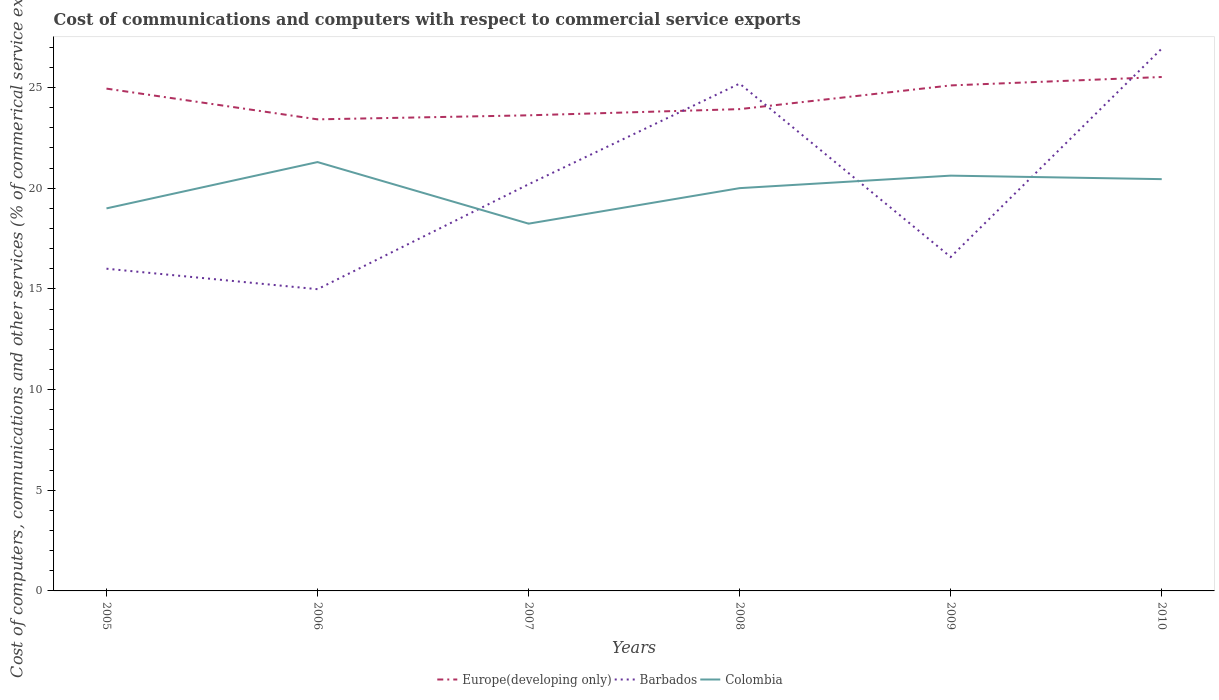Does the line corresponding to Europe(developing only) intersect with the line corresponding to Barbados?
Keep it short and to the point. Yes. Across all years, what is the maximum cost of communications and computers in Europe(developing only)?
Ensure brevity in your answer.  23.42. What is the total cost of communications and computers in Colombia in the graph?
Offer a terse response. 3.06. What is the difference between the highest and the second highest cost of communications and computers in Colombia?
Make the answer very short. 3.06. What is the difference between the highest and the lowest cost of communications and computers in Colombia?
Offer a very short reply. 4. Is the cost of communications and computers in Colombia strictly greater than the cost of communications and computers in Barbados over the years?
Your answer should be compact. No. Does the graph contain grids?
Offer a terse response. No. Where does the legend appear in the graph?
Keep it short and to the point. Bottom center. How many legend labels are there?
Offer a terse response. 3. What is the title of the graph?
Provide a succinct answer. Cost of communications and computers with respect to commercial service exports. What is the label or title of the X-axis?
Provide a succinct answer. Years. What is the label or title of the Y-axis?
Offer a very short reply. Cost of computers, communications and other services (% of commerical service exports). What is the Cost of computers, communications and other services (% of commerical service exports) of Europe(developing only) in 2005?
Provide a short and direct response. 24.95. What is the Cost of computers, communications and other services (% of commerical service exports) of Barbados in 2005?
Ensure brevity in your answer.  16. What is the Cost of computers, communications and other services (% of commerical service exports) in Colombia in 2005?
Offer a very short reply. 19. What is the Cost of computers, communications and other services (% of commerical service exports) of Europe(developing only) in 2006?
Offer a terse response. 23.42. What is the Cost of computers, communications and other services (% of commerical service exports) of Barbados in 2006?
Provide a succinct answer. 14.99. What is the Cost of computers, communications and other services (% of commerical service exports) in Colombia in 2006?
Your answer should be very brief. 21.3. What is the Cost of computers, communications and other services (% of commerical service exports) in Europe(developing only) in 2007?
Your answer should be compact. 23.62. What is the Cost of computers, communications and other services (% of commerical service exports) of Barbados in 2007?
Your answer should be compact. 20.2. What is the Cost of computers, communications and other services (% of commerical service exports) in Colombia in 2007?
Provide a succinct answer. 18.24. What is the Cost of computers, communications and other services (% of commerical service exports) in Europe(developing only) in 2008?
Your answer should be very brief. 23.93. What is the Cost of computers, communications and other services (% of commerical service exports) of Barbados in 2008?
Your answer should be very brief. 25.2. What is the Cost of computers, communications and other services (% of commerical service exports) of Colombia in 2008?
Make the answer very short. 20. What is the Cost of computers, communications and other services (% of commerical service exports) in Europe(developing only) in 2009?
Your response must be concise. 25.11. What is the Cost of computers, communications and other services (% of commerical service exports) in Barbados in 2009?
Give a very brief answer. 16.58. What is the Cost of computers, communications and other services (% of commerical service exports) of Colombia in 2009?
Make the answer very short. 20.63. What is the Cost of computers, communications and other services (% of commerical service exports) of Europe(developing only) in 2010?
Offer a very short reply. 25.52. What is the Cost of computers, communications and other services (% of commerical service exports) in Barbados in 2010?
Your answer should be very brief. 26.93. What is the Cost of computers, communications and other services (% of commerical service exports) in Colombia in 2010?
Offer a terse response. 20.45. Across all years, what is the maximum Cost of computers, communications and other services (% of commerical service exports) in Europe(developing only)?
Your answer should be compact. 25.52. Across all years, what is the maximum Cost of computers, communications and other services (% of commerical service exports) of Barbados?
Make the answer very short. 26.93. Across all years, what is the maximum Cost of computers, communications and other services (% of commerical service exports) of Colombia?
Your answer should be very brief. 21.3. Across all years, what is the minimum Cost of computers, communications and other services (% of commerical service exports) of Europe(developing only)?
Your answer should be very brief. 23.42. Across all years, what is the minimum Cost of computers, communications and other services (% of commerical service exports) of Barbados?
Keep it short and to the point. 14.99. Across all years, what is the minimum Cost of computers, communications and other services (% of commerical service exports) of Colombia?
Offer a terse response. 18.24. What is the total Cost of computers, communications and other services (% of commerical service exports) in Europe(developing only) in the graph?
Offer a terse response. 146.55. What is the total Cost of computers, communications and other services (% of commerical service exports) of Barbados in the graph?
Ensure brevity in your answer.  119.9. What is the total Cost of computers, communications and other services (% of commerical service exports) of Colombia in the graph?
Your answer should be very brief. 119.62. What is the difference between the Cost of computers, communications and other services (% of commerical service exports) of Europe(developing only) in 2005 and that in 2006?
Offer a terse response. 1.53. What is the difference between the Cost of computers, communications and other services (% of commerical service exports) of Barbados in 2005 and that in 2006?
Your response must be concise. 1.02. What is the difference between the Cost of computers, communications and other services (% of commerical service exports) of Colombia in 2005 and that in 2006?
Your answer should be very brief. -2.3. What is the difference between the Cost of computers, communications and other services (% of commerical service exports) of Europe(developing only) in 2005 and that in 2007?
Offer a terse response. 1.33. What is the difference between the Cost of computers, communications and other services (% of commerical service exports) in Barbados in 2005 and that in 2007?
Keep it short and to the point. -4.19. What is the difference between the Cost of computers, communications and other services (% of commerical service exports) in Colombia in 2005 and that in 2007?
Make the answer very short. 0.76. What is the difference between the Cost of computers, communications and other services (% of commerical service exports) of Europe(developing only) in 2005 and that in 2008?
Make the answer very short. 1.02. What is the difference between the Cost of computers, communications and other services (% of commerical service exports) in Barbados in 2005 and that in 2008?
Provide a succinct answer. -9.19. What is the difference between the Cost of computers, communications and other services (% of commerical service exports) of Colombia in 2005 and that in 2008?
Keep it short and to the point. -1.01. What is the difference between the Cost of computers, communications and other services (% of commerical service exports) of Europe(developing only) in 2005 and that in 2009?
Provide a short and direct response. -0.16. What is the difference between the Cost of computers, communications and other services (% of commerical service exports) in Barbados in 2005 and that in 2009?
Offer a very short reply. -0.58. What is the difference between the Cost of computers, communications and other services (% of commerical service exports) in Colombia in 2005 and that in 2009?
Keep it short and to the point. -1.63. What is the difference between the Cost of computers, communications and other services (% of commerical service exports) of Europe(developing only) in 2005 and that in 2010?
Keep it short and to the point. -0.58. What is the difference between the Cost of computers, communications and other services (% of commerical service exports) in Barbados in 2005 and that in 2010?
Make the answer very short. -10.93. What is the difference between the Cost of computers, communications and other services (% of commerical service exports) in Colombia in 2005 and that in 2010?
Your answer should be compact. -1.45. What is the difference between the Cost of computers, communications and other services (% of commerical service exports) of Europe(developing only) in 2006 and that in 2007?
Ensure brevity in your answer.  -0.2. What is the difference between the Cost of computers, communications and other services (% of commerical service exports) in Barbados in 2006 and that in 2007?
Offer a very short reply. -5.21. What is the difference between the Cost of computers, communications and other services (% of commerical service exports) in Colombia in 2006 and that in 2007?
Your response must be concise. 3.06. What is the difference between the Cost of computers, communications and other services (% of commerical service exports) of Europe(developing only) in 2006 and that in 2008?
Make the answer very short. -0.51. What is the difference between the Cost of computers, communications and other services (% of commerical service exports) of Barbados in 2006 and that in 2008?
Provide a short and direct response. -10.21. What is the difference between the Cost of computers, communications and other services (% of commerical service exports) in Colombia in 2006 and that in 2008?
Make the answer very short. 1.29. What is the difference between the Cost of computers, communications and other services (% of commerical service exports) in Europe(developing only) in 2006 and that in 2009?
Your response must be concise. -1.69. What is the difference between the Cost of computers, communications and other services (% of commerical service exports) of Barbados in 2006 and that in 2009?
Ensure brevity in your answer.  -1.6. What is the difference between the Cost of computers, communications and other services (% of commerical service exports) of Colombia in 2006 and that in 2009?
Your response must be concise. 0.67. What is the difference between the Cost of computers, communications and other services (% of commerical service exports) in Europe(developing only) in 2006 and that in 2010?
Your answer should be very brief. -2.1. What is the difference between the Cost of computers, communications and other services (% of commerical service exports) in Barbados in 2006 and that in 2010?
Ensure brevity in your answer.  -11.95. What is the difference between the Cost of computers, communications and other services (% of commerical service exports) in Colombia in 2006 and that in 2010?
Give a very brief answer. 0.85. What is the difference between the Cost of computers, communications and other services (% of commerical service exports) in Europe(developing only) in 2007 and that in 2008?
Your response must be concise. -0.31. What is the difference between the Cost of computers, communications and other services (% of commerical service exports) of Barbados in 2007 and that in 2008?
Your response must be concise. -5. What is the difference between the Cost of computers, communications and other services (% of commerical service exports) of Colombia in 2007 and that in 2008?
Keep it short and to the point. -1.76. What is the difference between the Cost of computers, communications and other services (% of commerical service exports) of Europe(developing only) in 2007 and that in 2009?
Make the answer very short. -1.49. What is the difference between the Cost of computers, communications and other services (% of commerical service exports) of Barbados in 2007 and that in 2009?
Provide a succinct answer. 3.61. What is the difference between the Cost of computers, communications and other services (% of commerical service exports) of Colombia in 2007 and that in 2009?
Your response must be concise. -2.38. What is the difference between the Cost of computers, communications and other services (% of commerical service exports) in Europe(developing only) in 2007 and that in 2010?
Your answer should be compact. -1.9. What is the difference between the Cost of computers, communications and other services (% of commerical service exports) of Barbados in 2007 and that in 2010?
Make the answer very short. -6.74. What is the difference between the Cost of computers, communications and other services (% of commerical service exports) in Colombia in 2007 and that in 2010?
Your answer should be very brief. -2.21. What is the difference between the Cost of computers, communications and other services (% of commerical service exports) of Europe(developing only) in 2008 and that in 2009?
Your answer should be very brief. -1.18. What is the difference between the Cost of computers, communications and other services (% of commerical service exports) of Barbados in 2008 and that in 2009?
Make the answer very short. 8.61. What is the difference between the Cost of computers, communications and other services (% of commerical service exports) in Colombia in 2008 and that in 2009?
Ensure brevity in your answer.  -0.62. What is the difference between the Cost of computers, communications and other services (% of commerical service exports) in Europe(developing only) in 2008 and that in 2010?
Make the answer very short. -1.6. What is the difference between the Cost of computers, communications and other services (% of commerical service exports) in Barbados in 2008 and that in 2010?
Provide a short and direct response. -1.74. What is the difference between the Cost of computers, communications and other services (% of commerical service exports) in Colombia in 2008 and that in 2010?
Make the answer very short. -0.45. What is the difference between the Cost of computers, communications and other services (% of commerical service exports) of Europe(developing only) in 2009 and that in 2010?
Provide a succinct answer. -0.42. What is the difference between the Cost of computers, communications and other services (% of commerical service exports) in Barbados in 2009 and that in 2010?
Provide a short and direct response. -10.35. What is the difference between the Cost of computers, communications and other services (% of commerical service exports) in Colombia in 2009 and that in 2010?
Your answer should be compact. 0.17. What is the difference between the Cost of computers, communications and other services (% of commerical service exports) in Europe(developing only) in 2005 and the Cost of computers, communications and other services (% of commerical service exports) in Barbados in 2006?
Your response must be concise. 9.96. What is the difference between the Cost of computers, communications and other services (% of commerical service exports) of Europe(developing only) in 2005 and the Cost of computers, communications and other services (% of commerical service exports) of Colombia in 2006?
Provide a short and direct response. 3.65. What is the difference between the Cost of computers, communications and other services (% of commerical service exports) of Barbados in 2005 and the Cost of computers, communications and other services (% of commerical service exports) of Colombia in 2006?
Make the answer very short. -5.3. What is the difference between the Cost of computers, communications and other services (% of commerical service exports) of Europe(developing only) in 2005 and the Cost of computers, communications and other services (% of commerical service exports) of Barbados in 2007?
Make the answer very short. 4.75. What is the difference between the Cost of computers, communications and other services (% of commerical service exports) of Europe(developing only) in 2005 and the Cost of computers, communications and other services (% of commerical service exports) of Colombia in 2007?
Your response must be concise. 6.71. What is the difference between the Cost of computers, communications and other services (% of commerical service exports) of Barbados in 2005 and the Cost of computers, communications and other services (% of commerical service exports) of Colombia in 2007?
Give a very brief answer. -2.24. What is the difference between the Cost of computers, communications and other services (% of commerical service exports) of Europe(developing only) in 2005 and the Cost of computers, communications and other services (% of commerical service exports) of Barbados in 2008?
Offer a terse response. -0.25. What is the difference between the Cost of computers, communications and other services (% of commerical service exports) of Europe(developing only) in 2005 and the Cost of computers, communications and other services (% of commerical service exports) of Colombia in 2008?
Keep it short and to the point. 4.94. What is the difference between the Cost of computers, communications and other services (% of commerical service exports) of Barbados in 2005 and the Cost of computers, communications and other services (% of commerical service exports) of Colombia in 2008?
Your response must be concise. -4. What is the difference between the Cost of computers, communications and other services (% of commerical service exports) of Europe(developing only) in 2005 and the Cost of computers, communications and other services (% of commerical service exports) of Barbados in 2009?
Provide a succinct answer. 8.36. What is the difference between the Cost of computers, communications and other services (% of commerical service exports) in Europe(developing only) in 2005 and the Cost of computers, communications and other services (% of commerical service exports) in Colombia in 2009?
Provide a short and direct response. 4.32. What is the difference between the Cost of computers, communications and other services (% of commerical service exports) in Barbados in 2005 and the Cost of computers, communications and other services (% of commerical service exports) in Colombia in 2009?
Provide a succinct answer. -4.62. What is the difference between the Cost of computers, communications and other services (% of commerical service exports) of Europe(developing only) in 2005 and the Cost of computers, communications and other services (% of commerical service exports) of Barbados in 2010?
Keep it short and to the point. -1.99. What is the difference between the Cost of computers, communications and other services (% of commerical service exports) in Europe(developing only) in 2005 and the Cost of computers, communications and other services (% of commerical service exports) in Colombia in 2010?
Keep it short and to the point. 4.5. What is the difference between the Cost of computers, communications and other services (% of commerical service exports) in Barbados in 2005 and the Cost of computers, communications and other services (% of commerical service exports) in Colombia in 2010?
Make the answer very short. -4.45. What is the difference between the Cost of computers, communications and other services (% of commerical service exports) of Europe(developing only) in 2006 and the Cost of computers, communications and other services (% of commerical service exports) of Barbados in 2007?
Offer a terse response. 3.22. What is the difference between the Cost of computers, communications and other services (% of commerical service exports) in Europe(developing only) in 2006 and the Cost of computers, communications and other services (% of commerical service exports) in Colombia in 2007?
Ensure brevity in your answer.  5.18. What is the difference between the Cost of computers, communications and other services (% of commerical service exports) of Barbados in 2006 and the Cost of computers, communications and other services (% of commerical service exports) of Colombia in 2007?
Your response must be concise. -3.25. What is the difference between the Cost of computers, communications and other services (% of commerical service exports) of Europe(developing only) in 2006 and the Cost of computers, communications and other services (% of commerical service exports) of Barbados in 2008?
Provide a succinct answer. -1.78. What is the difference between the Cost of computers, communications and other services (% of commerical service exports) in Europe(developing only) in 2006 and the Cost of computers, communications and other services (% of commerical service exports) in Colombia in 2008?
Make the answer very short. 3.42. What is the difference between the Cost of computers, communications and other services (% of commerical service exports) in Barbados in 2006 and the Cost of computers, communications and other services (% of commerical service exports) in Colombia in 2008?
Your response must be concise. -5.02. What is the difference between the Cost of computers, communications and other services (% of commerical service exports) of Europe(developing only) in 2006 and the Cost of computers, communications and other services (% of commerical service exports) of Barbados in 2009?
Offer a very short reply. 6.84. What is the difference between the Cost of computers, communications and other services (% of commerical service exports) of Europe(developing only) in 2006 and the Cost of computers, communications and other services (% of commerical service exports) of Colombia in 2009?
Your answer should be very brief. 2.8. What is the difference between the Cost of computers, communications and other services (% of commerical service exports) of Barbados in 2006 and the Cost of computers, communications and other services (% of commerical service exports) of Colombia in 2009?
Offer a terse response. -5.64. What is the difference between the Cost of computers, communications and other services (% of commerical service exports) of Europe(developing only) in 2006 and the Cost of computers, communications and other services (% of commerical service exports) of Barbados in 2010?
Ensure brevity in your answer.  -3.51. What is the difference between the Cost of computers, communications and other services (% of commerical service exports) of Europe(developing only) in 2006 and the Cost of computers, communications and other services (% of commerical service exports) of Colombia in 2010?
Provide a short and direct response. 2.97. What is the difference between the Cost of computers, communications and other services (% of commerical service exports) of Barbados in 2006 and the Cost of computers, communications and other services (% of commerical service exports) of Colombia in 2010?
Provide a short and direct response. -5.47. What is the difference between the Cost of computers, communications and other services (% of commerical service exports) in Europe(developing only) in 2007 and the Cost of computers, communications and other services (% of commerical service exports) in Barbados in 2008?
Your answer should be compact. -1.58. What is the difference between the Cost of computers, communications and other services (% of commerical service exports) of Europe(developing only) in 2007 and the Cost of computers, communications and other services (% of commerical service exports) of Colombia in 2008?
Give a very brief answer. 3.62. What is the difference between the Cost of computers, communications and other services (% of commerical service exports) in Barbados in 2007 and the Cost of computers, communications and other services (% of commerical service exports) in Colombia in 2008?
Keep it short and to the point. 0.19. What is the difference between the Cost of computers, communications and other services (% of commerical service exports) of Europe(developing only) in 2007 and the Cost of computers, communications and other services (% of commerical service exports) of Barbados in 2009?
Your answer should be compact. 7.04. What is the difference between the Cost of computers, communications and other services (% of commerical service exports) of Europe(developing only) in 2007 and the Cost of computers, communications and other services (% of commerical service exports) of Colombia in 2009?
Give a very brief answer. 3. What is the difference between the Cost of computers, communications and other services (% of commerical service exports) of Barbados in 2007 and the Cost of computers, communications and other services (% of commerical service exports) of Colombia in 2009?
Your response must be concise. -0.43. What is the difference between the Cost of computers, communications and other services (% of commerical service exports) of Europe(developing only) in 2007 and the Cost of computers, communications and other services (% of commerical service exports) of Barbados in 2010?
Provide a short and direct response. -3.31. What is the difference between the Cost of computers, communications and other services (% of commerical service exports) of Europe(developing only) in 2007 and the Cost of computers, communications and other services (% of commerical service exports) of Colombia in 2010?
Your answer should be compact. 3.17. What is the difference between the Cost of computers, communications and other services (% of commerical service exports) of Barbados in 2007 and the Cost of computers, communications and other services (% of commerical service exports) of Colombia in 2010?
Make the answer very short. -0.26. What is the difference between the Cost of computers, communications and other services (% of commerical service exports) in Europe(developing only) in 2008 and the Cost of computers, communications and other services (% of commerical service exports) in Barbados in 2009?
Give a very brief answer. 7.34. What is the difference between the Cost of computers, communications and other services (% of commerical service exports) in Europe(developing only) in 2008 and the Cost of computers, communications and other services (% of commerical service exports) in Colombia in 2009?
Keep it short and to the point. 3.3. What is the difference between the Cost of computers, communications and other services (% of commerical service exports) of Barbados in 2008 and the Cost of computers, communications and other services (% of commerical service exports) of Colombia in 2009?
Your response must be concise. 4.57. What is the difference between the Cost of computers, communications and other services (% of commerical service exports) in Europe(developing only) in 2008 and the Cost of computers, communications and other services (% of commerical service exports) in Barbados in 2010?
Your response must be concise. -3.01. What is the difference between the Cost of computers, communications and other services (% of commerical service exports) of Europe(developing only) in 2008 and the Cost of computers, communications and other services (% of commerical service exports) of Colombia in 2010?
Ensure brevity in your answer.  3.48. What is the difference between the Cost of computers, communications and other services (% of commerical service exports) of Barbados in 2008 and the Cost of computers, communications and other services (% of commerical service exports) of Colombia in 2010?
Ensure brevity in your answer.  4.74. What is the difference between the Cost of computers, communications and other services (% of commerical service exports) in Europe(developing only) in 2009 and the Cost of computers, communications and other services (% of commerical service exports) in Barbados in 2010?
Keep it short and to the point. -1.83. What is the difference between the Cost of computers, communications and other services (% of commerical service exports) in Europe(developing only) in 2009 and the Cost of computers, communications and other services (% of commerical service exports) in Colombia in 2010?
Provide a short and direct response. 4.65. What is the difference between the Cost of computers, communications and other services (% of commerical service exports) of Barbados in 2009 and the Cost of computers, communications and other services (% of commerical service exports) of Colombia in 2010?
Your response must be concise. -3.87. What is the average Cost of computers, communications and other services (% of commerical service exports) of Europe(developing only) per year?
Ensure brevity in your answer.  24.42. What is the average Cost of computers, communications and other services (% of commerical service exports) of Barbados per year?
Make the answer very short. 19.98. What is the average Cost of computers, communications and other services (% of commerical service exports) in Colombia per year?
Your answer should be very brief. 19.94. In the year 2005, what is the difference between the Cost of computers, communications and other services (% of commerical service exports) of Europe(developing only) and Cost of computers, communications and other services (% of commerical service exports) of Barbados?
Your answer should be compact. 8.94. In the year 2005, what is the difference between the Cost of computers, communications and other services (% of commerical service exports) in Europe(developing only) and Cost of computers, communications and other services (% of commerical service exports) in Colombia?
Offer a terse response. 5.95. In the year 2005, what is the difference between the Cost of computers, communications and other services (% of commerical service exports) of Barbados and Cost of computers, communications and other services (% of commerical service exports) of Colombia?
Your response must be concise. -3. In the year 2006, what is the difference between the Cost of computers, communications and other services (% of commerical service exports) of Europe(developing only) and Cost of computers, communications and other services (% of commerical service exports) of Barbados?
Offer a terse response. 8.43. In the year 2006, what is the difference between the Cost of computers, communications and other services (% of commerical service exports) in Europe(developing only) and Cost of computers, communications and other services (% of commerical service exports) in Colombia?
Provide a succinct answer. 2.12. In the year 2006, what is the difference between the Cost of computers, communications and other services (% of commerical service exports) in Barbados and Cost of computers, communications and other services (% of commerical service exports) in Colombia?
Offer a very short reply. -6.31. In the year 2007, what is the difference between the Cost of computers, communications and other services (% of commerical service exports) in Europe(developing only) and Cost of computers, communications and other services (% of commerical service exports) in Barbados?
Your answer should be very brief. 3.42. In the year 2007, what is the difference between the Cost of computers, communications and other services (% of commerical service exports) in Europe(developing only) and Cost of computers, communications and other services (% of commerical service exports) in Colombia?
Your answer should be very brief. 5.38. In the year 2007, what is the difference between the Cost of computers, communications and other services (% of commerical service exports) of Barbados and Cost of computers, communications and other services (% of commerical service exports) of Colombia?
Keep it short and to the point. 1.96. In the year 2008, what is the difference between the Cost of computers, communications and other services (% of commerical service exports) in Europe(developing only) and Cost of computers, communications and other services (% of commerical service exports) in Barbados?
Your answer should be very brief. -1.27. In the year 2008, what is the difference between the Cost of computers, communications and other services (% of commerical service exports) in Europe(developing only) and Cost of computers, communications and other services (% of commerical service exports) in Colombia?
Provide a succinct answer. 3.92. In the year 2008, what is the difference between the Cost of computers, communications and other services (% of commerical service exports) in Barbados and Cost of computers, communications and other services (% of commerical service exports) in Colombia?
Ensure brevity in your answer.  5.19. In the year 2009, what is the difference between the Cost of computers, communications and other services (% of commerical service exports) in Europe(developing only) and Cost of computers, communications and other services (% of commerical service exports) in Barbados?
Make the answer very short. 8.52. In the year 2009, what is the difference between the Cost of computers, communications and other services (% of commerical service exports) in Europe(developing only) and Cost of computers, communications and other services (% of commerical service exports) in Colombia?
Make the answer very short. 4.48. In the year 2009, what is the difference between the Cost of computers, communications and other services (% of commerical service exports) in Barbados and Cost of computers, communications and other services (% of commerical service exports) in Colombia?
Your response must be concise. -4.04. In the year 2010, what is the difference between the Cost of computers, communications and other services (% of commerical service exports) of Europe(developing only) and Cost of computers, communications and other services (% of commerical service exports) of Barbados?
Ensure brevity in your answer.  -1.41. In the year 2010, what is the difference between the Cost of computers, communications and other services (% of commerical service exports) of Europe(developing only) and Cost of computers, communications and other services (% of commerical service exports) of Colombia?
Offer a terse response. 5.07. In the year 2010, what is the difference between the Cost of computers, communications and other services (% of commerical service exports) in Barbados and Cost of computers, communications and other services (% of commerical service exports) in Colombia?
Offer a very short reply. 6.48. What is the ratio of the Cost of computers, communications and other services (% of commerical service exports) of Europe(developing only) in 2005 to that in 2006?
Provide a short and direct response. 1.07. What is the ratio of the Cost of computers, communications and other services (% of commerical service exports) of Barbados in 2005 to that in 2006?
Offer a terse response. 1.07. What is the ratio of the Cost of computers, communications and other services (% of commerical service exports) in Colombia in 2005 to that in 2006?
Your answer should be very brief. 0.89. What is the ratio of the Cost of computers, communications and other services (% of commerical service exports) of Europe(developing only) in 2005 to that in 2007?
Make the answer very short. 1.06. What is the ratio of the Cost of computers, communications and other services (% of commerical service exports) in Barbados in 2005 to that in 2007?
Provide a succinct answer. 0.79. What is the ratio of the Cost of computers, communications and other services (% of commerical service exports) of Colombia in 2005 to that in 2007?
Ensure brevity in your answer.  1.04. What is the ratio of the Cost of computers, communications and other services (% of commerical service exports) in Europe(developing only) in 2005 to that in 2008?
Your answer should be very brief. 1.04. What is the ratio of the Cost of computers, communications and other services (% of commerical service exports) of Barbados in 2005 to that in 2008?
Your response must be concise. 0.64. What is the ratio of the Cost of computers, communications and other services (% of commerical service exports) of Colombia in 2005 to that in 2008?
Make the answer very short. 0.95. What is the ratio of the Cost of computers, communications and other services (% of commerical service exports) in Barbados in 2005 to that in 2009?
Make the answer very short. 0.96. What is the ratio of the Cost of computers, communications and other services (% of commerical service exports) in Colombia in 2005 to that in 2009?
Give a very brief answer. 0.92. What is the ratio of the Cost of computers, communications and other services (% of commerical service exports) of Europe(developing only) in 2005 to that in 2010?
Give a very brief answer. 0.98. What is the ratio of the Cost of computers, communications and other services (% of commerical service exports) of Barbados in 2005 to that in 2010?
Offer a terse response. 0.59. What is the ratio of the Cost of computers, communications and other services (% of commerical service exports) of Colombia in 2005 to that in 2010?
Provide a succinct answer. 0.93. What is the ratio of the Cost of computers, communications and other services (% of commerical service exports) of Barbados in 2006 to that in 2007?
Offer a very short reply. 0.74. What is the ratio of the Cost of computers, communications and other services (% of commerical service exports) of Colombia in 2006 to that in 2007?
Make the answer very short. 1.17. What is the ratio of the Cost of computers, communications and other services (% of commerical service exports) in Europe(developing only) in 2006 to that in 2008?
Provide a succinct answer. 0.98. What is the ratio of the Cost of computers, communications and other services (% of commerical service exports) in Barbados in 2006 to that in 2008?
Give a very brief answer. 0.59. What is the ratio of the Cost of computers, communications and other services (% of commerical service exports) of Colombia in 2006 to that in 2008?
Provide a succinct answer. 1.06. What is the ratio of the Cost of computers, communications and other services (% of commerical service exports) of Europe(developing only) in 2006 to that in 2009?
Offer a very short reply. 0.93. What is the ratio of the Cost of computers, communications and other services (% of commerical service exports) in Barbados in 2006 to that in 2009?
Provide a short and direct response. 0.9. What is the ratio of the Cost of computers, communications and other services (% of commerical service exports) in Colombia in 2006 to that in 2009?
Provide a short and direct response. 1.03. What is the ratio of the Cost of computers, communications and other services (% of commerical service exports) of Europe(developing only) in 2006 to that in 2010?
Keep it short and to the point. 0.92. What is the ratio of the Cost of computers, communications and other services (% of commerical service exports) in Barbados in 2006 to that in 2010?
Your response must be concise. 0.56. What is the ratio of the Cost of computers, communications and other services (% of commerical service exports) in Colombia in 2006 to that in 2010?
Make the answer very short. 1.04. What is the ratio of the Cost of computers, communications and other services (% of commerical service exports) in Europe(developing only) in 2007 to that in 2008?
Your answer should be very brief. 0.99. What is the ratio of the Cost of computers, communications and other services (% of commerical service exports) of Barbados in 2007 to that in 2008?
Provide a short and direct response. 0.8. What is the ratio of the Cost of computers, communications and other services (% of commerical service exports) of Colombia in 2007 to that in 2008?
Your answer should be compact. 0.91. What is the ratio of the Cost of computers, communications and other services (% of commerical service exports) of Europe(developing only) in 2007 to that in 2009?
Your answer should be very brief. 0.94. What is the ratio of the Cost of computers, communications and other services (% of commerical service exports) in Barbados in 2007 to that in 2009?
Your answer should be compact. 1.22. What is the ratio of the Cost of computers, communications and other services (% of commerical service exports) of Colombia in 2007 to that in 2009?
Make the answer very short. 0.88. What is the ratio of the Cost of computers, communications and other services (% of commerical service exports) in Europe(developing only) in 2007 to that in 2010?
Make the answer very short. 0.93. What is the ratio of the Cost of computers, communications and other services (% of commerical service exports) in Barbados in 2007 to that in 2010?
Ensure brevity in your answer.  0.75. What is the ratio of the Cost of computers, communications and other services (% of commerical service exports) in Colombia in 2007 to that in 2010?
Your response must be concise. 0.89. What is the ratio of the Cost of computers, communications and other services (% of commerical service exports) in Europe(developing only) in 2008 to that in 2009?
Your answer should be very brief. 0.95. What is the ratio of the Cost of computers, communications and other services (% of commerical service exports) of Barbados in 2008 to that in 2009?
Keep it short and to the point. 1.52. What is the ratio of the Cost of computers, communications and other services (% of commerical service exports) of Colombia in 2008 to that in 2009?
Make the answer very short. 0.97. What is the ratio of the Cost of computers, communications and other services (% of commerical service exports) in Barbados in 2008 to that in 2010?
Provide a succinct answer. 0.94. What is the ratio of the Cost of computers, communications and other services (% of commerical service exports) in Colombia in 2008 to that in 2010?
Offer a terse response. 0.98. What is the ratio of the Cost of computers, communications and other services (% of commerical service exports) in Europe(developing only) in 2009 to that in 2010?
Your response must be concise. 0.98. What is the ratio of the Cost of computers, communications and other services (% of commerical service exports) of Barbados in 2009 to that in 2010?
Ensure brevity in your answer.  0.62. What is the ratio of the Cost of computers, communications and other services (% of commerical service exports) of Colombia in 2009 to that in 2010?
Keep it short and to the point. 1.01. What is the difference between the highest and the second highest Cost of computers, communications and other services (% of commerical service exports) of Europe(developing only)?
Give a very brief answer. 0.42. What is the difference between the highest and the second highest Cost of computers, communications and other services (% of commerical service exports) in Barbados?
Provide a succinct answer. 1.74. What is the difference between the highest and the second highest Cost of computers, communications and other services (% of commerical service exports) in Colombia?
Provide a short and direct response. 0.67. What is the difference between the highest and the lowest Cost of computers, communications and other services (% of commerical service exports) of Europe(developing only)?
Your response must be concise. 2.1. What is the difference between the highest and the lowest Cost of computers, communications and other services (% of commerical service exports) in Barbados?
Keep it short and to the point. 11.95. What is the difference between the highest and the lowest Cost of computers, communications and other services (% of commerical service exports) in Colombia?
Your answer should be compact. 3.06. 